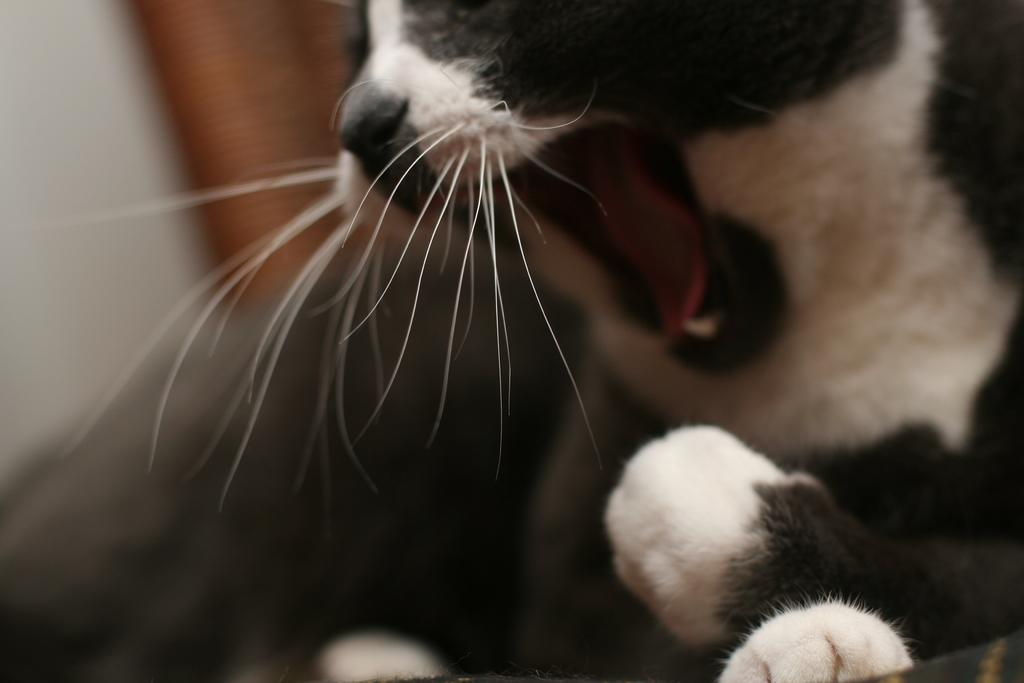What type of subject is present in the image? There is an animal in the image. What color scheme is used for the animal? The animal is in black and white color. Can you describe the background of the image? The background of the image is blurred. How many rabbits are interacting with the snails in the image? There are no rabbits or snails present in the image. What type of respect is shown by the animal in the image? The image does not depict any specific type of respect; it only shows an animal in black and white color with a blurred background. 